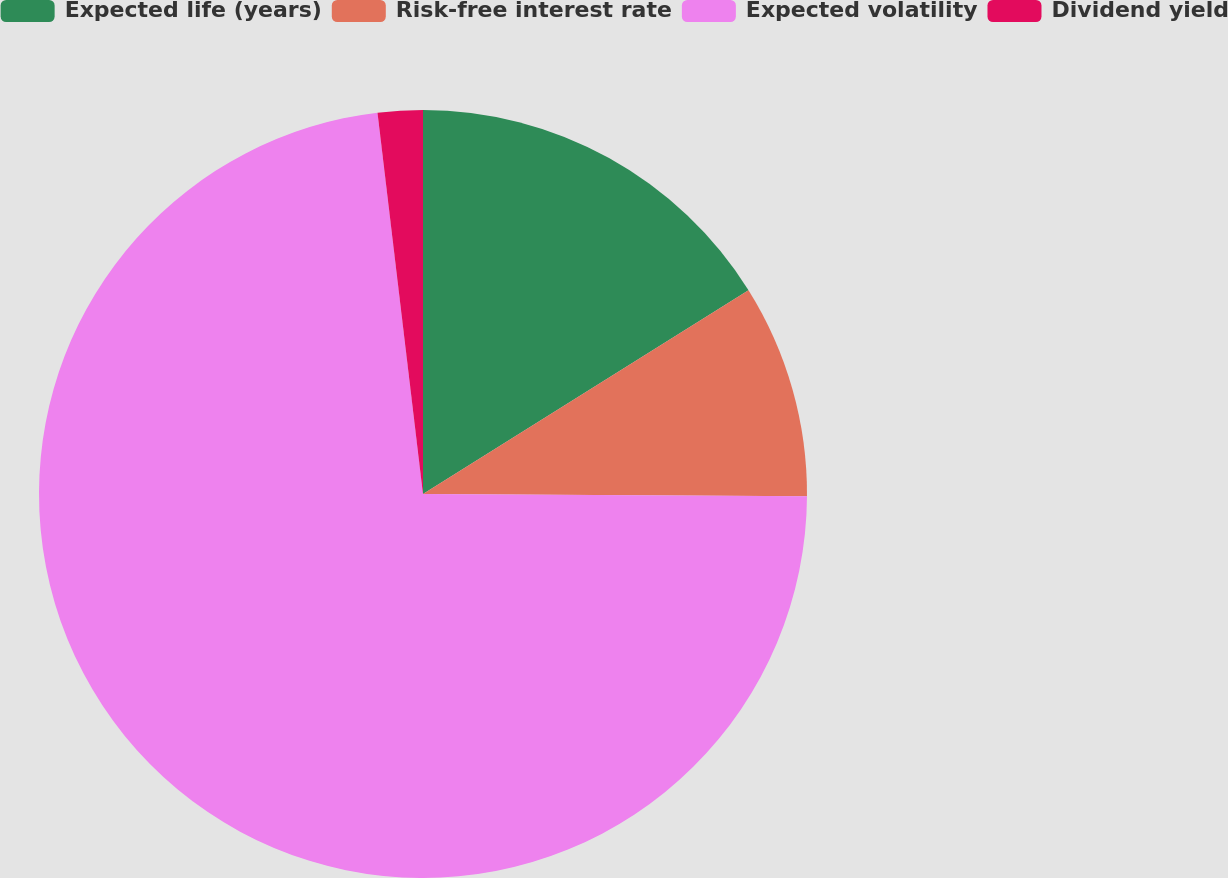Convert chart. <chart><loc_0><loc_0><loc_500><loc_500><pie_chart><fcel>Expected life (years)<fcel>Risk-free interest rate<fcel>Expected volatility<fcel>Dividend yield<nl><fcel>16.1%<fcel>8.99%<fcel>73.02%<fcel>1.89%<nl></chart> 